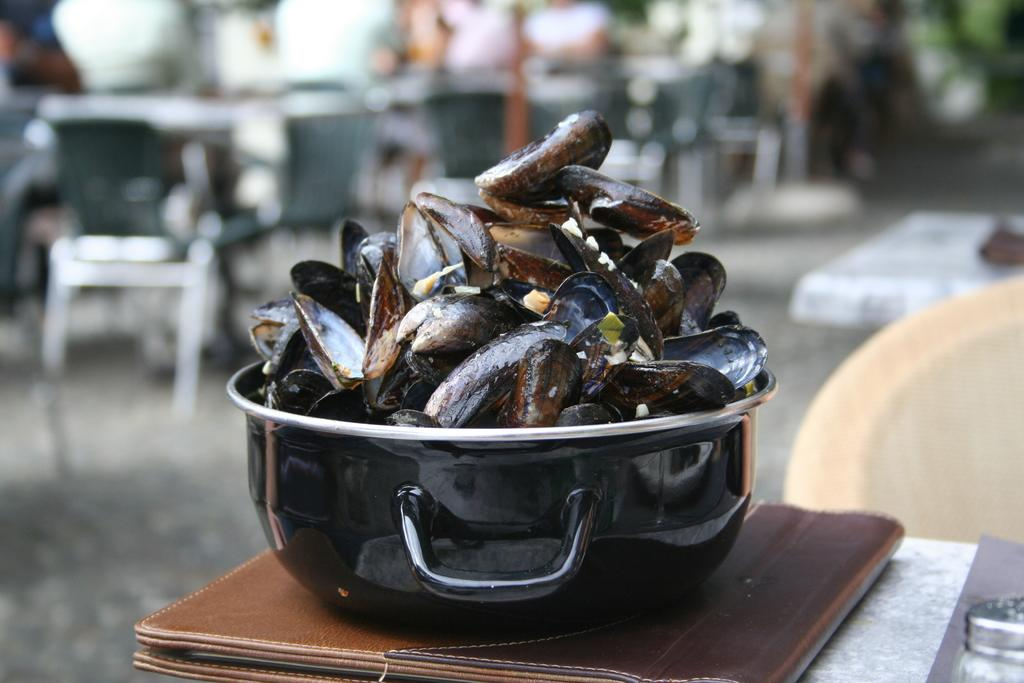What type of food is in the casserole in the image? There is a casserole with mussels in the image. What else is placed on the table in the image? There is a file placed on the table in the image. Where are the casserole and the file located in the image? Both the casserole and the file are placed on a table in the image. Can you describe the background of the image? The background of the image is blurred. What verse from a poem can be seen written on the mussels in the image? There is no verse from a poem written on the mussels in the image; it is a casserole dish with mussels. How does the person in the image express regret about the number of mussels they ate? There is no person present in the image, and therefore no expression of regret can be observed. 